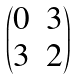Convert formula to latex. <formula><loc_0><loc_0><loc_500><loc_500>\begin{pmatrix} 0 & 3 \\ 3 & 2 \end{pmatrix}</formula> 